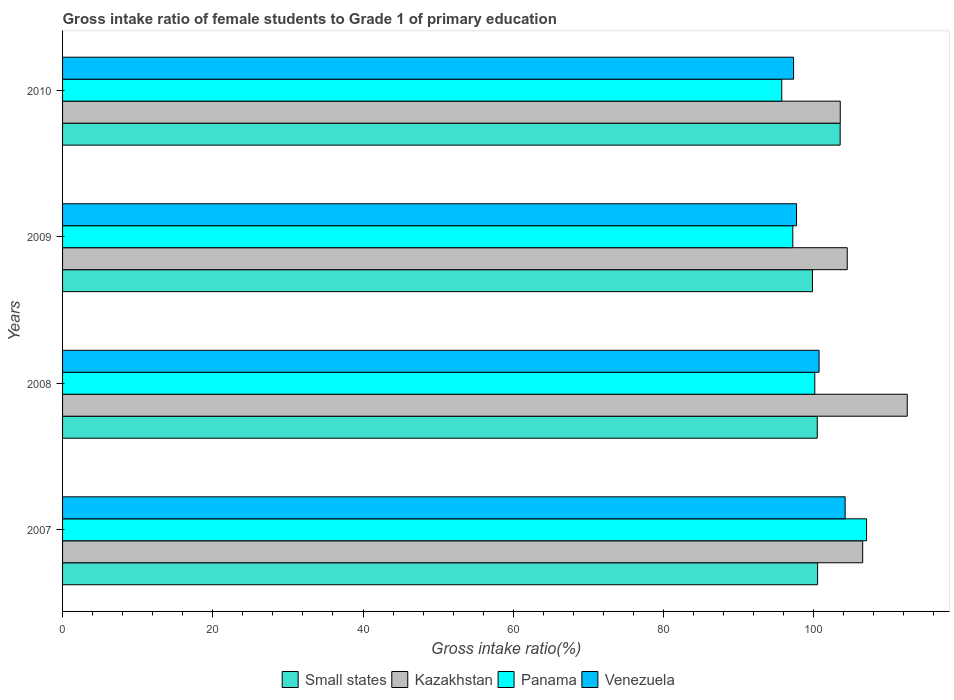How many different coloured bars are there?
Offer a terse response. 4. How many groups of bars are there?
Ensure brevity in your answer.  4. Are the number of bars per tick equal to the number of legend labels?
Ensure brevity in your answer.  Yes. Are the number of bars on each tick of the Y-axis equal?
Provide a succinct answer. Yes. How many bars are there on the 3rd tick from the top?
Give a very brief answer. 4. What is the label of the 1st group of bars from the top?
Make the answer very short. 2010. In how many cases, is the number of bars for a given year not equal to the number of legend labels?
Keep it short and to the point. 0. What is the gross intake ratio in Venezuela in 2010?
Ensure brevity in your answer.  97.33. Across all years, what is the maximum gross intake ratio in Small states?
Your answer should be very brief. 103.53. Across all years, what is the minimum gross intake ratio in Venezuela?
Your answer should be very brief. 97.33. In which year was the gross intake ratio in Panama maximum?
Your answer should be very brief. 2007. What is the total gross intake ratio in Venezuela in the graph?
Provide a succinct answer. 399.96. What is the difference between the gross intake ratio in Panama in 2008 and that in 2009?
Make the answer very short. 2.93. What is the difference between the gross intake ratio in Small states in 2009 and the gross intake ratio in Kazakhstan in 2008?
Ensure brevity in your answer.  -12.62. What is the average gross intake ratio in Kazakhstan per year?
Your answer should be compact. 106.75. In the year 2007, what is the difference between the gross intake ratio in Kazakhstan and gross intake ratio in Small states?
Your answer should be very brief. 6. What is the ratio of the gross intake ratio in Venezuela in 2007 to that in 2008?
Your response must be concise. 1.03. Is the gross intake ratio in Kazakhstan in 2007 less than that in 2010?
Your answer should be very brief. No. What is the difference between the highest and the second highest gross intake ratio in Venezuela?
Ensure brevity in your answer.  3.47. What is the difference between the highest and the lowest gross intake ratio in Small states?
Ensure brevity in your answer.  3.69. In how many years, is the gross intake ratio in Small states greater than the average gross intake ratio in Small states taken over all years?
Offer a terse response. 1. Is it the case that in every year, the sum of the gross intake ratio in Venezuela and gross intake ratio in Small states is greater than the sum of gross intake ratio in Kazakhstan and gross intake ratio in Panama?
Ensure brevity in your answer.  No. What does the 2nd bar from the top in 2008 represents?
Your response must be concise. Panama. What does the 2nd bar from the bottom in 2009 represents?
Give a very brief answer. Kazakhstan. How many bars are there?
Ensure brevity in your answer.  16. Are all the bars in the graph horizontal?
Give a very brief answer. Yes. How many years are there in the graph?
Your response must be concise. 4. What is the difference between two consecutive major ticks on the X-axis?
Your answer should be very brief. 20. Are the values on the major ticks of X-axis written in scientific E-notation?
Provide a succinct answer. No. Does the graph contain grids?
Offer a terse response. No. Where does the legend appear in the graph?
Provide a succinct answer. Bottom center. How many legend labels are there?
Give a very brief answer. 4. How are the legend labels stacked?
Your response must be concise. Horizontal. What is the title of the graph?
Your answer should be compact. Gross intake ratio of female students to Grade 1 of primary education. What is the label or title of the X-axis?
Keep it short and to the point. Gross intake ratio(%). What is the label or title of the Y-axis?
Your answer should be compact. Years. What is the Gross intake ratio(%) of Small states in 2007?
Offer a terse response. 100.53. What is the Gross intake ratio(%) in Kazakhstan in 2007?
Keep it short and to the point. 106.53. What is the Gross intake ratio(%) in Panama in 2007?
Offer a terse response. 107.04. What is the Gross intake ratio(%) of Venezuela in 2007?
Provide a short and direct response. 104.19. What is the Gross intake ratio(%) in Small states in 2008?
Your answer should be very brief. 100.48. What is the Gross intake ratio(%) in Kazakhstan in 2008?
Your answer should be compact. 112.46. What is the Gross intake ratio(%) of Panama in 2008?
Keep it short and to the point. 100.15. What is the Gross intake ratio(%) of Venezuela in 2008?
Provide a short and direct response. 100.72. What is the Gross intake ratio(%) of Small states in 2009?
Ensure brevity in your answer.  99.84. What is the Gross intake ratio(%) in Kazakhstan in 2009?
Provide a succinct answer. 104.47. What is the Gross intake ratio(%) of Panama in 2009?
Your response must be concise. 97.23. What is the Gross intake ratio(%) in Venezuela in 2009?
Make the answer very short. 97.72. What is the Gross intake ratio(%) in Small states in 2010?
Offer a terse response. 103.53. What is the Gross intake ratio(%) in Kazakhstan in 2010?
Provide a short and direct response. 103.54. What is the Gross intake ratio(%) in Panama in 2010?
Make the answer very short. 95.75. What is the Gross intake ratio(%) in Venezuela in 2010?
Your answer should be very brief. 97.33. Across all years, what is the maximum Gross intake ratio(%) in Small states?
Your answer should be compact. 103.53. Across all years, what is the maximum Gross intake ratio(%) in Kazakhstan?
Your response must be concise. 112.46. Across all years, what is the maximum Gross intake ratio(%) in Panama?
Provide a short and direct response. 107.04. Across all years, what is the maximum Gross intake ratio(%) in Venezuela?
Your answer should be very brief. 104.19. Across all years, what is the minimum Gross intake ratio(%) in Small states?
Your response must be concise. 99.84. Across all years, what is the minimum Gross intake ratio(%) in Kazakhstan?
Your answer should be very brief. 103.54. Across all years, what is the minimum Gross intake ratio(%) of Panama?
Your response must be concise. 95.75. Across all years, what is the minimum Gross intake ratio(%) of Venezuela?
Give a very brief answer. 97.33. What is the total Gross intake ratio(%) of Small states in the graph?
Your answer should be compact. 404.38. What is the total Gross intake ratio(%) of Kazakhstan in the graph?
Make the answer very short. 427. What is the total Gross intake ratio(%) in Panama in the graph?
Ensure brevity in your answer.  400.18. What is the total Gross intake ratio(%) of Venezuela in the graph?
Offer a terse response. 399.96. What is the difference between the Gross intake ratio(%) of Small states in 2007 and that in 2008?
Ensure brevity in your answer.  0.05. What is the difference between the Gross intake ratio(%) of Kazakhstan in 2007 and that in 2008?
Ensure brevity in your answer.  -5.93. What is the difference between the Gross intake ratio(%) in Panama in 2007 and that in 2008?
Provide a short and direct response. 6.89. What is the difference between the Gross intake ratio(%) of Venezuela in 2007 and that in 2008?
Ensure brevity in your answer.  3.47. What is the difference between the Gross intake ratio(%) in Small states in 2007 and that in 2009?
Ensure brevity in your answer.  0.69. What is the difference between the Gross intake ratio(%) in Kazakhstan in 2007 and that in 2009?
Offer a terse response. 2.05. What is the difference between the Gross intake ratio(%) in Panama in 2007 and that in 2009?
Make the answer very short. 9.82. What is the difference between the Gross intake ratio(%) of Venezuela in 2007 and that in 2009?
Make the answer very short. 6.47. What is the difference between the Gross intake ratio(%) in Small states in 2007 and that in 2010?
Your response must be concise. -3. What is the difference between the Gross intake ratio(%) of Kazakhstan in 2007 and that in 2010?
Give a very brief answer. 2.99. What is the difference between the Gross intake ratio(%) of Panama in 2007 and that in 2010?
Give a very brief answer. 11.29. What is the difference between the Gross intake ratio(%) in Venezuela in 2007 and that in 2010?
Your answer should be compact. 6.87. What is the difference between the Gross intake ratio(%) in Small states in 2008 and that in 2009?
Make the answer very short. 0.64. What is the difference between the Gross intake ratio(%) in Kazakhstan in 2008 and that in 2009?
Keep it short and to the point. 7.99. What is the difference between the Gross intake ratio(%) of Panama in 2008 and that in 2009?
Your response must be concise. 2.93. What is the difference between the Gross intake ratio(%) of Venezuela in 2008 and that in 2009?
Offer a terse response. 3. What is the difference between the Gross intake ratio(%) of Small states in 2008 and that in 2010?
Offer a very short reply. -3.05. What is the difference between the Gross intake ratio(%) of Kazakhstan in 2008 and that in 2010?
Your response must be concise. 8.92. What is the difference between the Gross intake ratio(%) of Panama in 2008 and that in 2010?
Your answer should be compact. 4.4. What is the difference between the Gross intake ratio(%) of Venezuela in 2008 and that in 2010?
Your answer should be very brief. 3.39. What is the difference between the Gross intake ratio(%) in Small states in 2009 and that in 2010?
Provide a short and direct response. -3.69. What is the difference between the Gross intake ratio(%) in Kazakhstan in 2009 and that in 2010?
Offer a terse response. 0.93. What is the difference between the Gross intake ratio(%) of Panama in 2009 and that in 2010?
Ensure brevity in your answer.  1.47. What is the difference between the Gross intake ratio(%) of Venezuela in 2009 and that in 2010?
Give a very brief answer. 0.39. What is the difference between the Gross intake ratio(%) of Small states in 2007 and the Gross intake ratio(%) of Kazakhstan in 2008?
Your answer should be compact. -11.94. What is the difference between the Gross intake ratio(%) in Small states in 2007 and the Gross intake ratio(%) in Panama in 2008?
Offer a very short reply. 0.37. What is the difference between the Gross intake ratio(%) of Small states in 2007 and the Gross intake ratio(%) of Venezuela in 2008?
Provide a short and direct response. -0.19. What is the difference between the Gross intake ratio(%) of Kazakhstan in 2007 and the Gross intake ratio(%) of Panama in 2008?
Ensure brevity in your answer.  6.38. What is the difference between the Gross intake ratio(%) in Kazakhstan in 2007 and the Gross intake ratio(%) in Venezuela in 2008?
Give a very brief answer. 5.81. What is the difference between the Gross intake ratio(%) in Panama in 2007 and the Gross intake ratio(%) in Venezuela in 2008?
Give a very brief answer. 6.33. What is the difference between the Gross intake ratio(%) of Small states in 2007 and the Gross intake ratio(%) of Kazakhstan in 2009?
Provide a short and direct response. -3.95. What is the difference between the Gross intake ratio(%) of Small states in 2007 and the Gross intake ratio(%) of Panama in 2009?
Ensure brevity in your answer.  3.3. What is the difference between the Gross intake ratio(%) in Small states in 2007 and the Gross intake ratio(%) in Venezuela in 2009?
Your response must be concise. 2.81. What is the difference between the Gross intake ratio(%) in Kazakhstan in 2007 and the Gross intake ratio(%) in Panama in 2009?
Ensure brevity in your answer.  9.3. What is the difference between the Gross intake ratio(%) of Kazakhstan in 2007 and the Gross intake ratio(%) of Venezuela in 2009?
Ensure brevity in your answer.  8.81. What is the difference between the Gross intake ratio(%) in Panama in 2007 and the Gross intake ratio(%) in Venezuela in 2009?
Your response must be concise. 9.32. What is the difference between the Gross intake ratio(%) of Small states in 2007 and the Gross intake ratio(%) of Kazakhstan in 2010?
Give a very brief answer. -3.01. What is the difference between the Gross intake ratio(%) of Small states in 2007 and the Gross intake ratio(%) of Panama in 2010?
Your answer should be compact. 4.77. What is the difference between the Gross intake ratio(%) of Small states in 2007 and the Gross intake ratio(%) of Venezuela in 2010?
Provide a succinct answer. 3.2. What is the difference between the Gross intake ratio(%) of Kazakhstan in 2007 and the Gross intake ratio(%) of Panama in 2010?
Provide a short and direct response. 10.77. What is the difference between the Gross intake ratio(%) of Kazakhstan in 2007 and the Gross intake ratio(%) of Venezuela in 2010?
Keep it short and to the point. 9.2. What is the difference between the Gross intake ratio(%) in Panama in 2007 and the Gross intake ratio(%) in Venezuela in 2010?
Provide a short and direct response. 9.72. What is the difference between the Gross intake ratio(%) in Small states in 2008 and the Gross intake ratio(%) in Kazakhstan in 2009?
Provide a short and direct response. -3.99. What is the difference between the Gross intake ratio(%) of Small states in 2008 and the Gross intake ratio(%) of Panama in 2009?
Your answer should be very brief. 3.25. What is the difference between the Gross intake ratio(%) of Small states in 2008 and the Gross intake ratio(%) of Venezuela in 2009?
Offer a very short reply. 2.76. What is the difference between the Gross intake ratio(%) in Kazakhstan in 2008 and the Gross intake ratio(%) in Panama in 2009?
Provide a succinct answer. 15.24. What is the difference between the Gross intake ratio(%) of Kazakhstan in 2008 and the Gross intake ratio(%) of Venezuela in 2009?
Provide a short and direct response. 14.74. What is the difference between the Gross intake ratio(%) in Panama in 2008 and the Gross intake ratio(%) in Venezuela in 2009?
Your answer should be very brief. 2.43. What is the difference between the Gross intake ratio(%) of Small states in 2008 and the Gross intake ratio(%) of Kazakhstan in 2010?
Your answer should be compact. -3.06. What is the difference between the Gross intake ratio(%) of Small states in 2008 and the Gross intake ratio(%) of Panama in 2010?
Offer a very short reply. 4.72. What is the difference between the Gross intake ratio(%) in Small states in 2008 and the Gross intake ratio(%) in Venezuela in 2010?
Make the answer very short. 3.15. What is the difference between the Gross intake ratio(%) of Kazakhstan in 2008 and the Gross intake ratio(%) of Panama in 2010?
Keep it short and to the point. 16.71. What is the difference between the Gross intake ratio(%) in Kazakhstan in 2008 and the Gross intake ratio(%) in Venezuela in 2010?
Make the answer very short. 15.14. What is the difference between the Gross intake ratio(%) in Panama in 2008 and the Gross intake ratio(%) in Venezuela in 2010?
Your answer should be very brief. 2.83. What is the difference between the Gross intake ratio(%) in Small states in 2009 and the Gross intake ratio(%) in Kazakhstan in 2010?
Make the answer very short. -3.7. What is the difference between the Gross intake ratio(%) of Small states in 2009 and the Gross intake ratio(%) of Panama in 2010?
Your answer should be very brief. 4.09. What is the difference between the Gross intake ratio(%) in Small states in 2009 and the Gross intake ratio(%) in Venezuela in 2010?
Your answer should be very brief. 2.52. What is the difference between the Gross intake ratio(%) of Kazakhstan in 2009 and the Gross intake ratio(%) of Panama in 2010?
Offer a terse response. 8.72. What is the difference between the Gross intake ratio(%) of Kazakhstan in 2009 and the Gross intake ratio(%) of Venezuela in 2010?
Ensure brevity in your answer.  7.15. What is the difference between the Gross intake ratio(%) of Panama in 2009 and the Gross intake ratio(%) of Venezuela in 2010?
Offer a very short reply. -0.1. What is the average Gross intake ratio(%) of Small states per year?
Provide a succinct answer. 101.09. What is the average Gross intake ratio(%) of Kazakhstan per year?
Make the answer very short. 106.75. What is the average Gross intake ratio(%) of Panama per year?
Provide a short and direct response. 100.04. What is the average Gross intake ratio(%) in Venezuela per year?
Your answer should be compact. 99.99. In the year 2007, what is the difference between the Gross intake ratio(%) in Small states and Gross intake ratio(%) in Kazakhstan?
Provide a short and direct response. -6. In the year 2007, what is the difference between the Gross intake ratio(%) of Small states and Gross intake ratio(%) of Panama?
Your response must be concise. -6.52. In the year 2007, what is the difference between the Gross intake ratio(%) of Small states and Gross intake ratio(%) of Venezuela?
Give a very brief answer. -3.67. In the year 2007, what is the difference between the Gross intake ratio(%) in Kazakhstan and Gross intake ratio(%) in Panama?
Provide a short and direct response. -0.52. In the year 2007, what is the difference between the Gross intake ratio(%) of Kazakhstan and Gross intake ratio(%) of Venezuela?
Offer a very short reply. 2.34. In the year 2007, what is the difference between the Gross intake ratio(%) in Panama and Gross intake ratio(%) in Venezuela?
Make the answer very short. 2.85. In the year 2008, what is the difference between the Gross intake ratio(%) in Small states and Gross intake ratio(%) in Kazakhstan?
Give a very brief answer. -11.98. In the year 2008, what is the difference between the Gross intake ratio(%) in Small states and Gross intake ratio(%) in Panama?
Your answer should be compact. 0.33. In the year 2008, what is the difference between the Gross intake ratio(%) in Small states and Gross intake ratio(%) in Venezuela?
Provide a succinct answer. -0.24. In the year 2008, what is the difference between the Gross intake ratio(%) in Kazakhstan and Gross intake ratio(%) in Panama?
Your response must be concise. 12.31. In the year 2008, what is the difference between the Gross intake ratio(%) in Kazakhstan and Gross intake ratio(%) in Venezuela?
Your answer should be very brief. 11.74. In the year 2008, what is the difference between the Gross intake ratio(%) of Panama and Gross intake ratio(%) of Venezuela?
Provide a short and direct response. -0.57. In the year 2009, what is the difference between the Gross intake ratio(%) in Small states and Gross intake ratio(%) in Kazakhstan?
Your answer should be compact. -4.63. In the year 2009, what is the difference between the Gross intake ratio(%) of Small states and Gross intake ratio(%) of Panama?
Your answer should be compact. 2.61. In the year 2009, what is the difference between the Gross intake ratio(%) in Small states and Gross intake ratio(%) in Venezuela?
Your answer should be very brief. 2.12. In the year 2009, what is the difference between the Gross intake ratio(%) in Kazakhstan and Gross intake ratio(%) in Panama?
Offer a terse response. 7.25. In the year 2009, what is the difference between the Gross intake ratio(%) of Kazakhstan and Gross intake ratio(%) of Venezuela?
Provide a short and direct response. 6.75. In the year 2009, what is the difference between the Gross intake ratio(%) in Panama and Gross intake ratio(%) in Venezuela?
Your answer should be very brief. -0.49. In the year 2010, what is the difference between the Gross intake ratio(%) in Small states and Gross intake ratio(%) in Kazakhstan?
Give a very brief answer. -0.01. In the year 2010, what is the difference between the Gross intake ratio(%) in Small states and Gross intake ratio(%) in Panama?
Offer a terse response. 7.77. In the year 2010, what is the difference between the Gross intake ratio(%) in Small states and Gross intake ratio(%) in Venezuela?
Your response must be concise. 6.2. In the year 2010, what is the difference between the Gross intake ratio(%) in Kazakhstan and Gross intake ratio(%) in Panama?
Make the answer very short. 7.79. In the year 2010, what is the difference between the Gross intake ratio(%) of Kazakhstan and Gross intake ratio(%) of Venezuela?
Offer a very short reply. 6.21. In the year 2010, what is the difference between the Gross intake ratio(%) of Panama and Gross intake ratio(%) of Venezuela?
Your answer should be compact. -1.57. What is the ratio of the Gross intake ratio(%) in Kazakhstan in 2007 to that in 2008?
Ensure brevity in your answer.  0.95. What is the ratio of the Gross intake ratio(%) of Panama in 2007 to that in 2008?
Your response must be concise. 1.07. What is the ratio of the Gross intake ratio(%) in Venezuela in 2007 to that in 2008?
Provide a succinct answer. 1.03. What is the ratio of the Gross intake ratio(%) of Kazakhstan in 2007 to that in 2009?
Provide a short and direct response. 1.02. What is the ratio of the Gross intake ratio(%) in Panama in 2007 to that in 2009?
Offer a terse response. 1.1. What is the ratio of the Gross intake ratio(%) in Venezuela in 2007 to that in 2009?
Give a very brief answer. 1.07. What is the ratio of the Gross intake ratio(%) in Small states in 2007 to that in 2010?
Ensure brevity in your answer.  0.97. What is the ratio of the Gross intake ratio(%) in Kazakhstan in 2007 to that in 2010?
Provide a short and direct response. 1.03. What is the ratio of the Gross intake ratio(%) in Panama in 2007 to that in 2010?
Provide a succinct answer. 1.12. What is the ratio of the Gross intake ratio(%) in Venezuela in 2007 to that in 2010?
Ensure brevity in your answer.  1.07. What is the ratio of the Gross intake ratio(%) in Small states in 2008 to that in 2009?
Your answer should be very brief. 1.01. What is the ratio of the Gross intake ratio(%) of Kazakhstan in 2008 to that in 2009?
Make the answer very short. 1.08. What is the ratio of the Gross intake ratio(%) of Panama in 2008 to that in 2009?
Offer a terse response. 1.03. What is the ratio of the Gross intake ratio(%) of Venezuela in 2008 to that in 2009?
Ensure brevity in your answer.  1.03. What is the ratio of the Gross intake ratio(%) of Small states in 2008 to that in 2010?
Ensure brevity in your answer.  0.97. What is the ratio of the Gross intake ratio(%) of Kazakhstan in 2008 to that in 2010?
Provide a succinct answer. 1.09. What is the ratio of the Gross intake ratio(%) of Panama in 2008 to that in 2010?
Your answer should be compact. 1.05. What is the ratio of the Gross intake ratio(%) of Venezuela in 2008 to that in 2010?
Provide a succinct answer. 1.03. What is the ratio of the Gross intake ratio(%) in Small states in 2009 to that in 2010?
Provide a short and direct response. 0.96. What is the ratio of the Gross intake ratio(%) of Kazakhstan in 2009 to that in 2010?
Make the answer very short. 1.01. What is the ratio of the Gross intake ratio(%) in Panama in 2009 to that in 2010?
Make the answer very short. 1.02. What is the difference between the highest and the second highest Gross intake ratio(%) in Small states?
Provide a succinct answer. 3. What is the difference between the highest and the second highest Gross intake ratio(%) in Kazakhstan?
Keep it short and to the point. 5.93. What is the difference between the highest and the second highest Gross intake ratio(%) in Panama?
Give a very brief answer. 6.89. What is the difference between the highest and the second highest Gross intake ratio(%) of Venezuela?
Offer a terse response. 3.47. What is the difference between the highest and the lowest Gross intake ratio(%) in Small states?
Offer a very short reply. 3.69. What is the difference between the highest and the lowest Gross intake ratio(%) in Kazakhstan?
Your answer should be very brief. 8.92. What is the difference between the highest and the lowest Gross intake ratio(%) of Panama?
Your answer should be very brief. 11.29. What is the difference between the highest and the lowest Gross intake ratio(%) in Venezuela?
Provide a short and direct response. 6.87. 